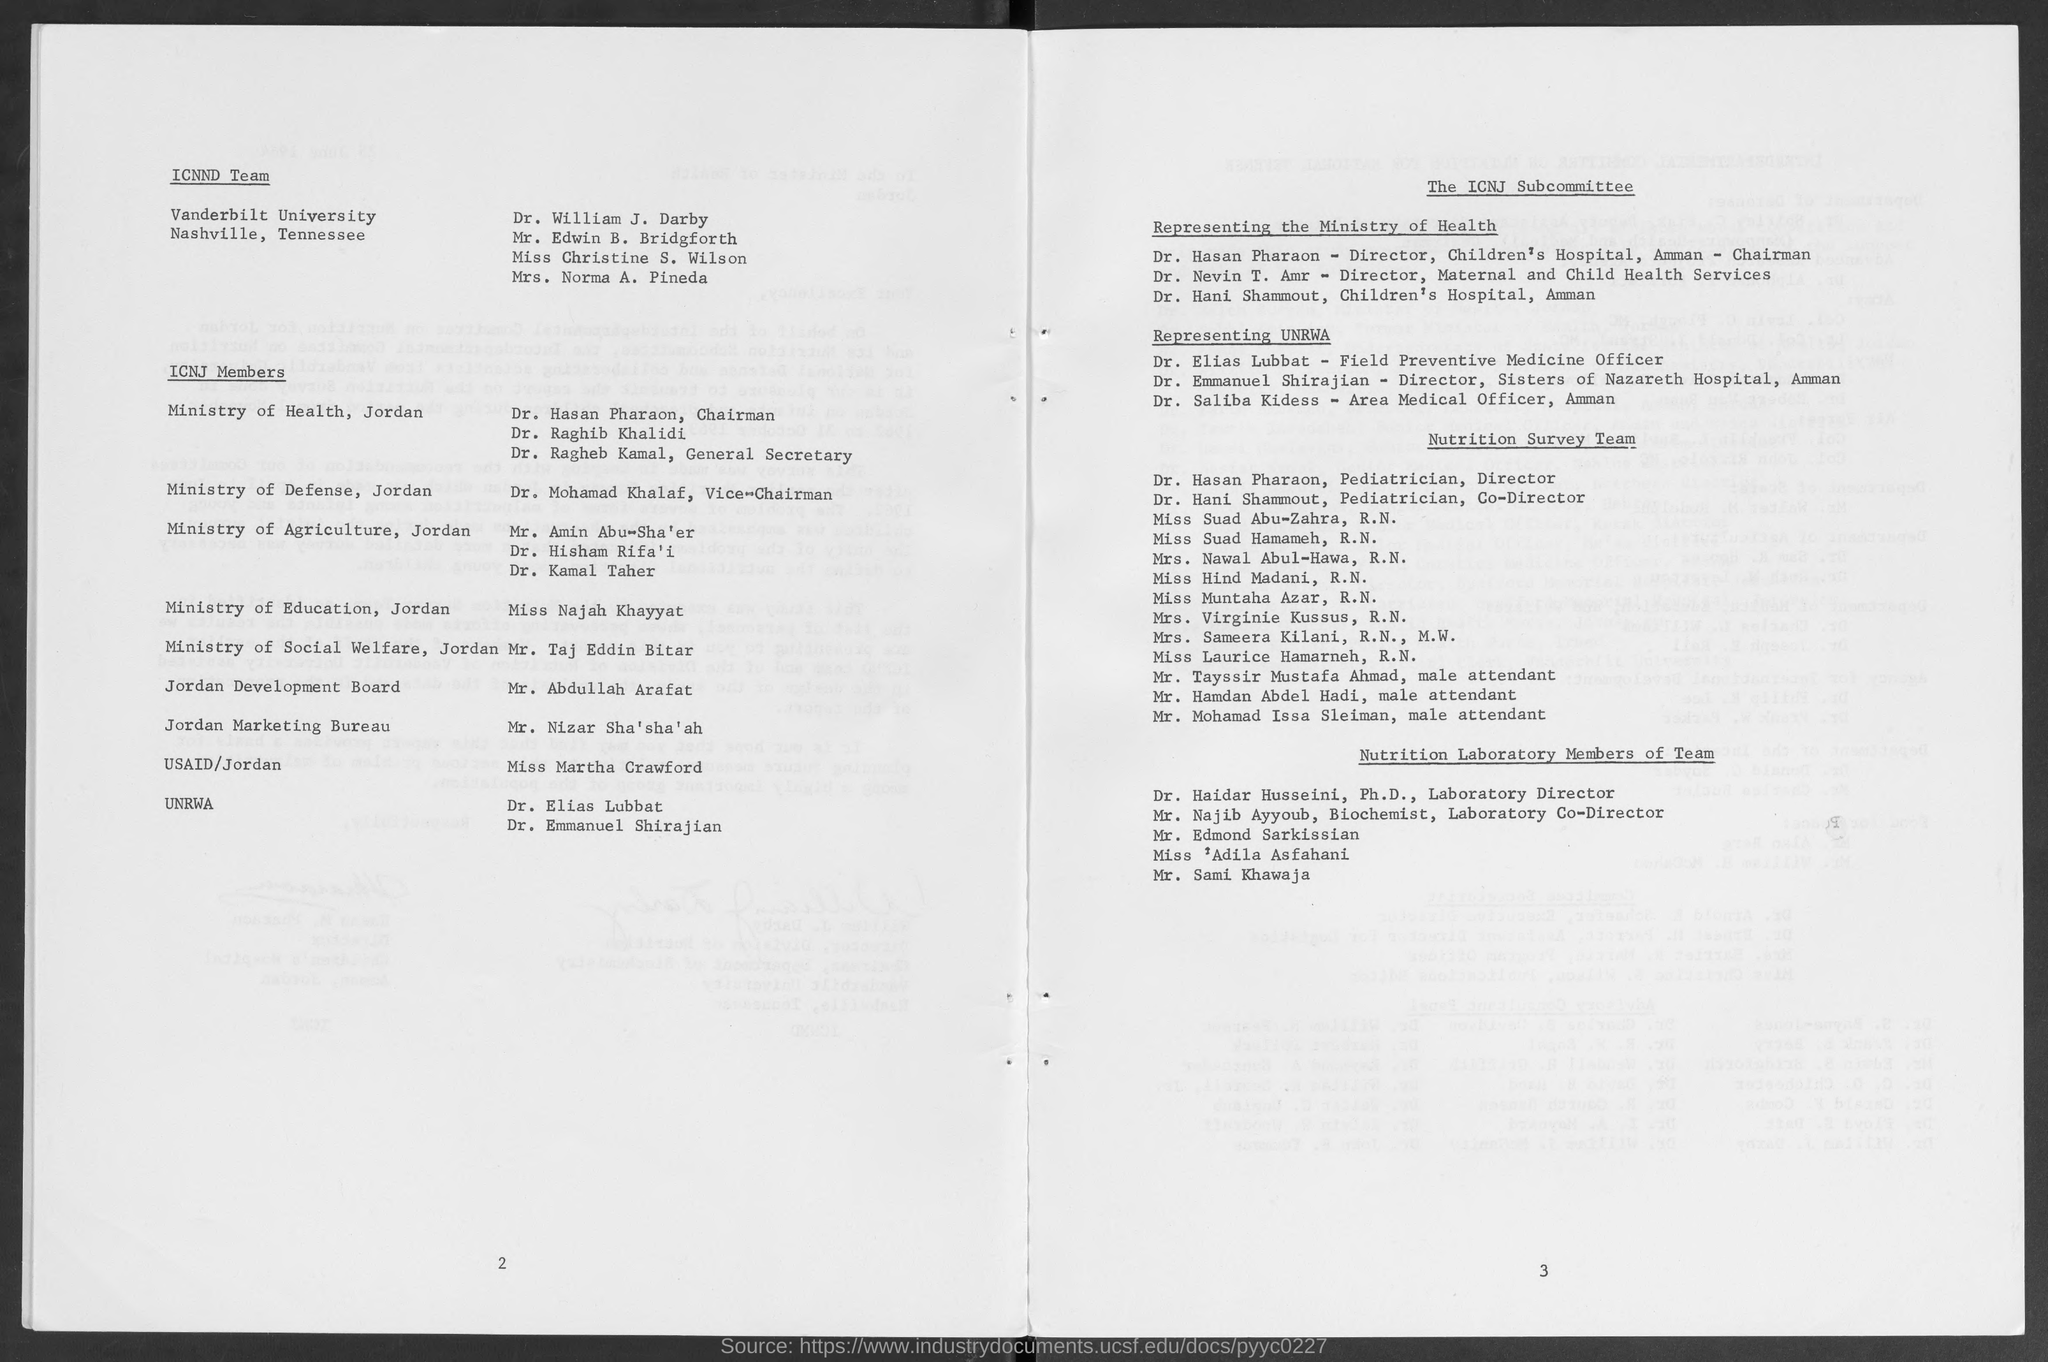Who is the chairman, ministry of health , jordan?
Provide a succinct answer. Dr. Hasan Pharaon. Who is vice- chairman, ministry of defense, jordan?
Offer a very short reply. Dr. Mohamad Khalaf. Who is the general secretary , ministry of health ?
Your answer should be very brief. Dr. Ragheb Kamal. Who is the director, maternal and child health services ?
Your answer should be compact. Dr. Nevin T. Amr. Who is the director, children's hospital, amman - chairman?
Make the answer very short. Dr. Hasan Pharaon. 